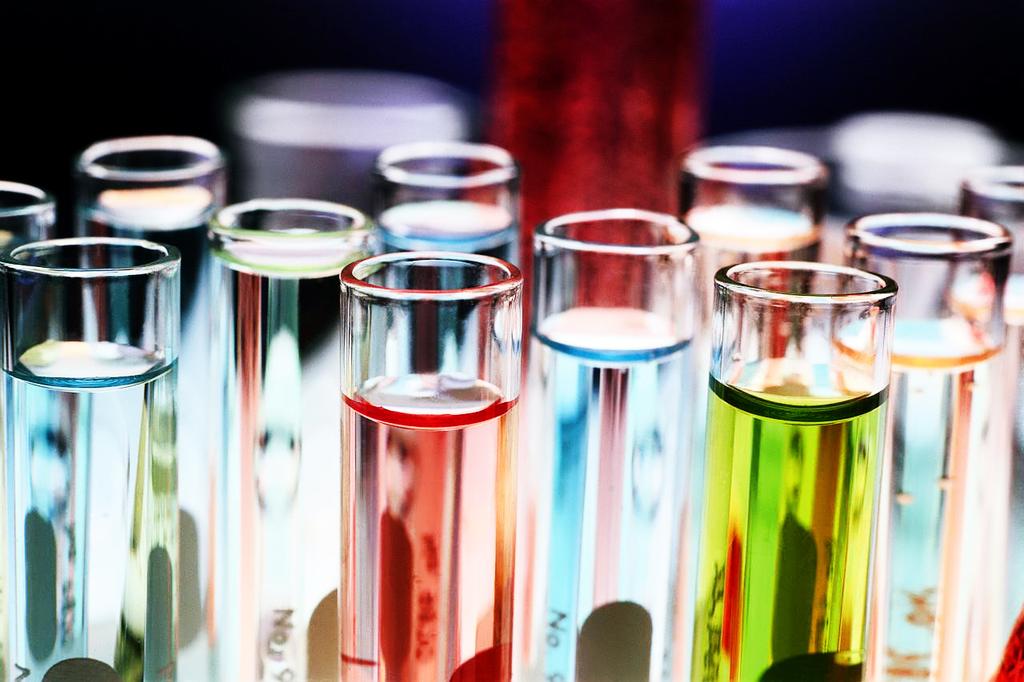What word is written on the blue test tube between the red and yellow?
Your response must be concise. No. 